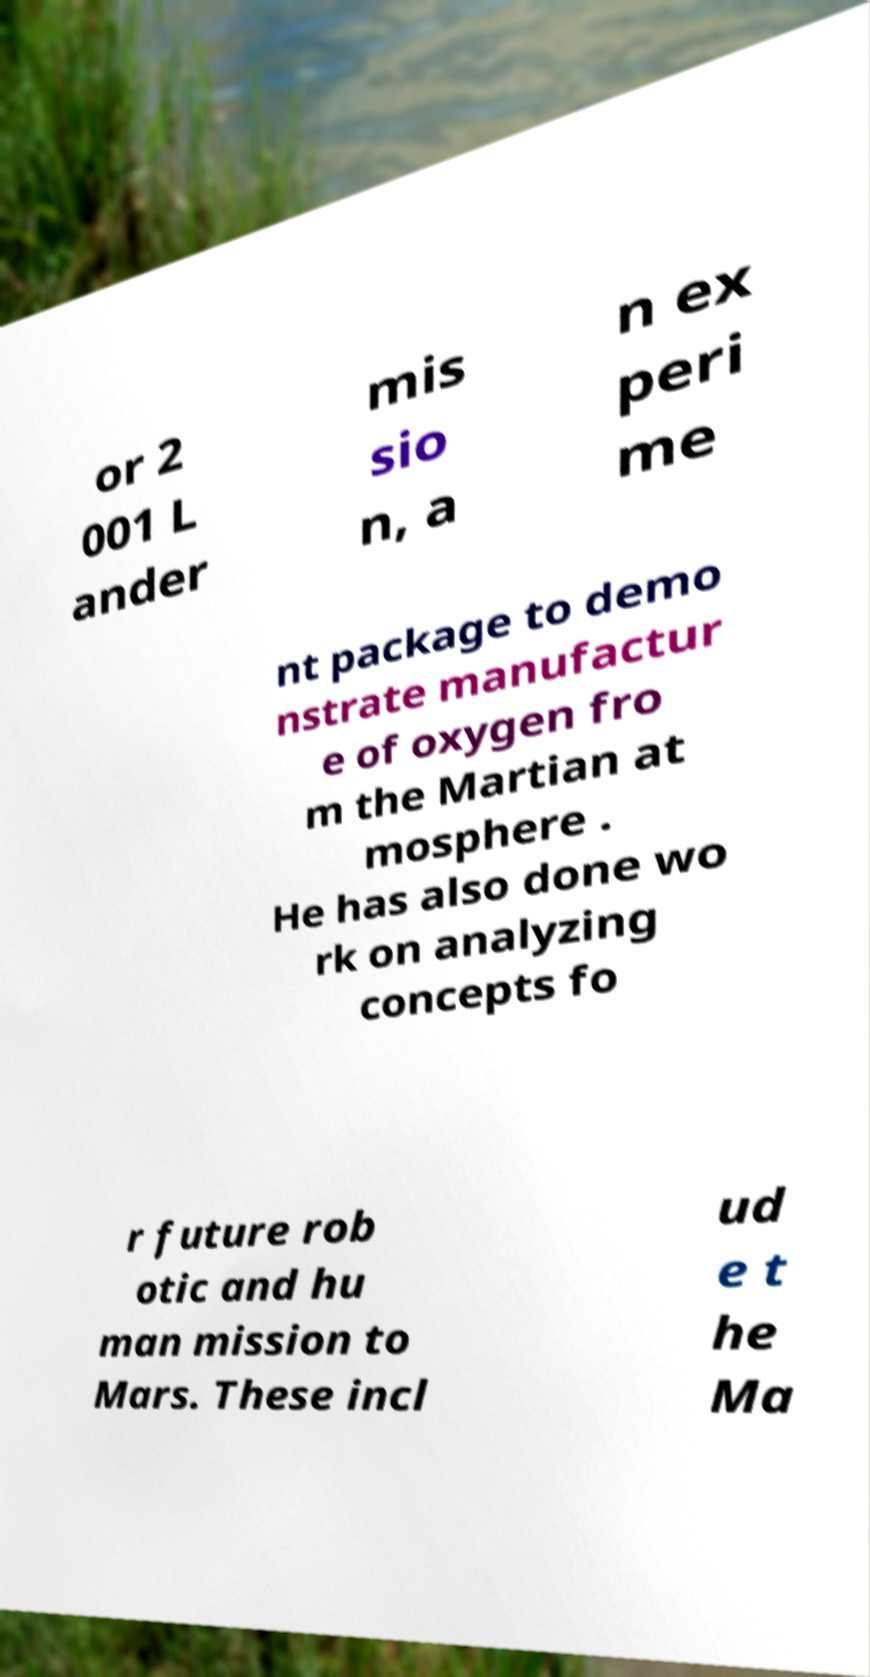Can you accurately transcribe the text from the provided image for me? or 2 001 L ander mis sio n, a n ex peri me nt package to demo nstrate manufactur e of oxygen fro m the Martian at mosphere . He has also done wo rk on analyzing concepts fo r future rob otic and hu man mission to Mars. These incl ud e t he Ma 